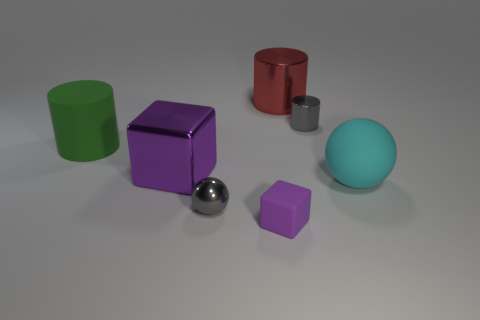Add 6 purple cubes. How many purple cubes are left? 8 Add 4 tiny things. How many tiny things exist? 7 Add 2 big purple metallic objects. How many objects exist? 9 Subtract all green cylinders. How many cylinders are left? 2 Subtract all big cylinders. How many cylinders are left? 1 Subtract 0 red spheres. How many objects are left? 7 Subtract all cylinders. How many objects are left? 4 Subtract 1 cubes. How many cubes are left? 1 Subtract all green cylinders. Subtract all blue blocks. How many cylinders are left? 2 Subtract all green blocks. How many green balls are left? 0 